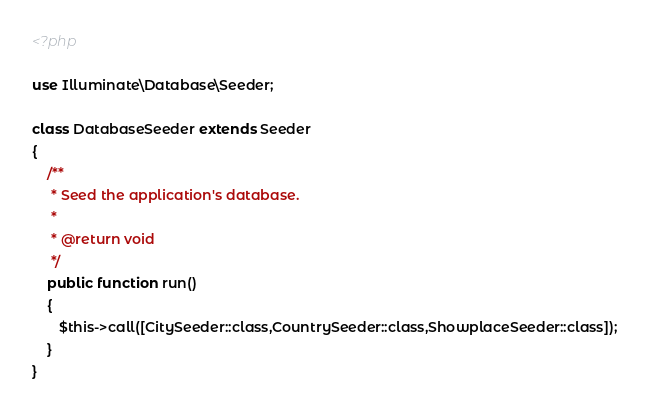Convert code to text. <code><loc_0><loc_0><loc_500><loc_500><_PHP_><?php

use Illuminate\Database\Seeder;

class DatabaseSeeder extends Seeder
{
    /**
     * Seed the application's database.
     *
     * @return void
     */
    public function run()
    {
       $this->call([CitySeeder::class,CountrySeeder::class,ShowplaceSeeder::class]);
    }
}
</code> 